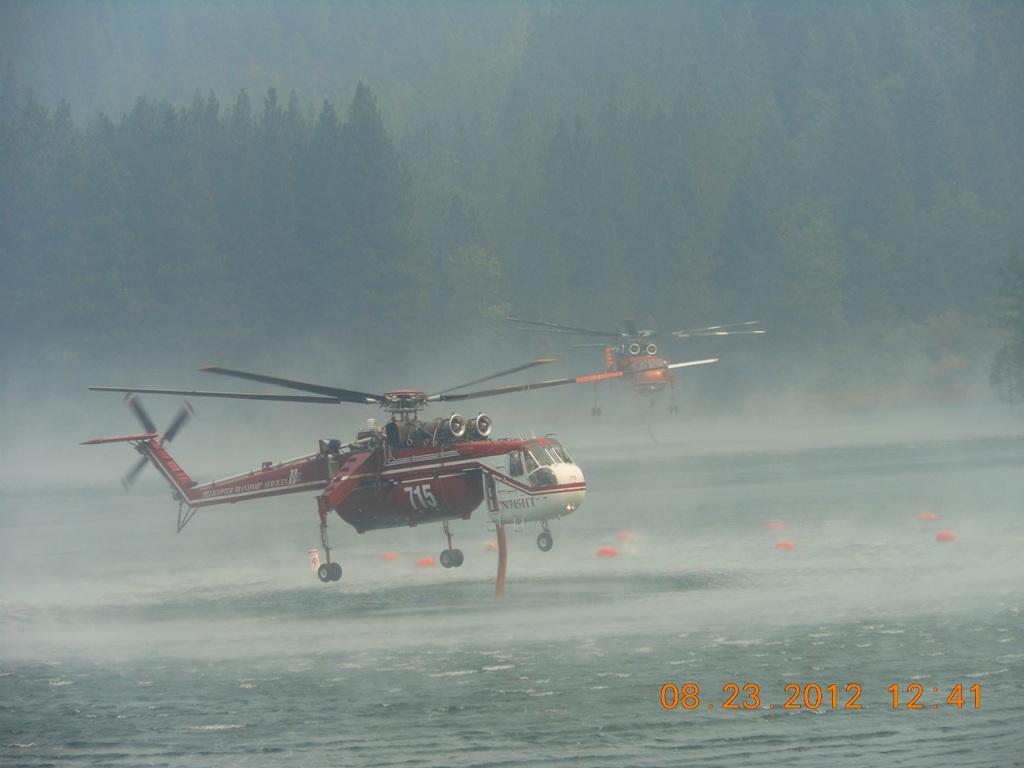Can you describe this image briefly? In the image there are two helicopters flying in the air above a sea, in the back there are trees all over the image. 